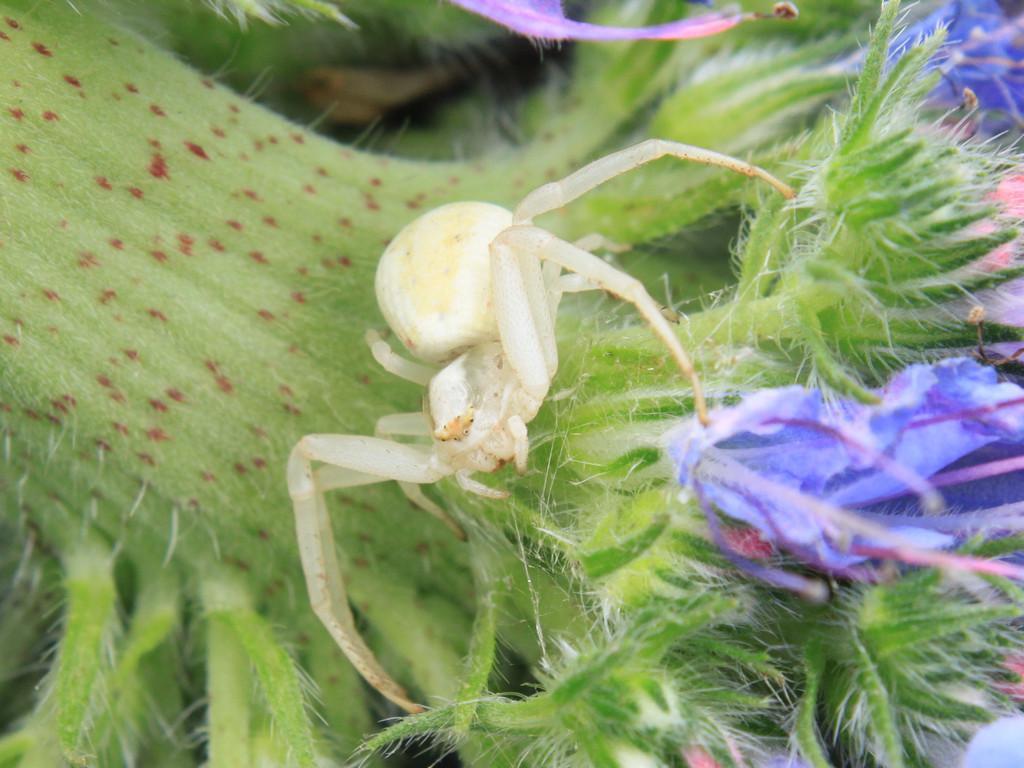Can you describe this image briefly? We can see a spider on a plant and on the right side we can see the flowers. 